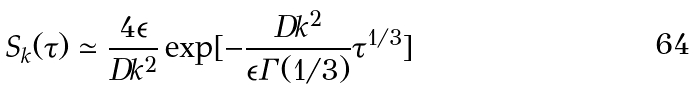<formula> <loc_0><loc_0><loc_500><loc_500>S _ { k } ( \tau ) \simeq \frac { 4 \epsilon } { D k ^ { 2 } } \exp [ - \frac { D k ^ { 2 } } { \epsilon \Gamma ( 1 / 3 ) } \tau ^ { 1 / 3 } ]</formula> 